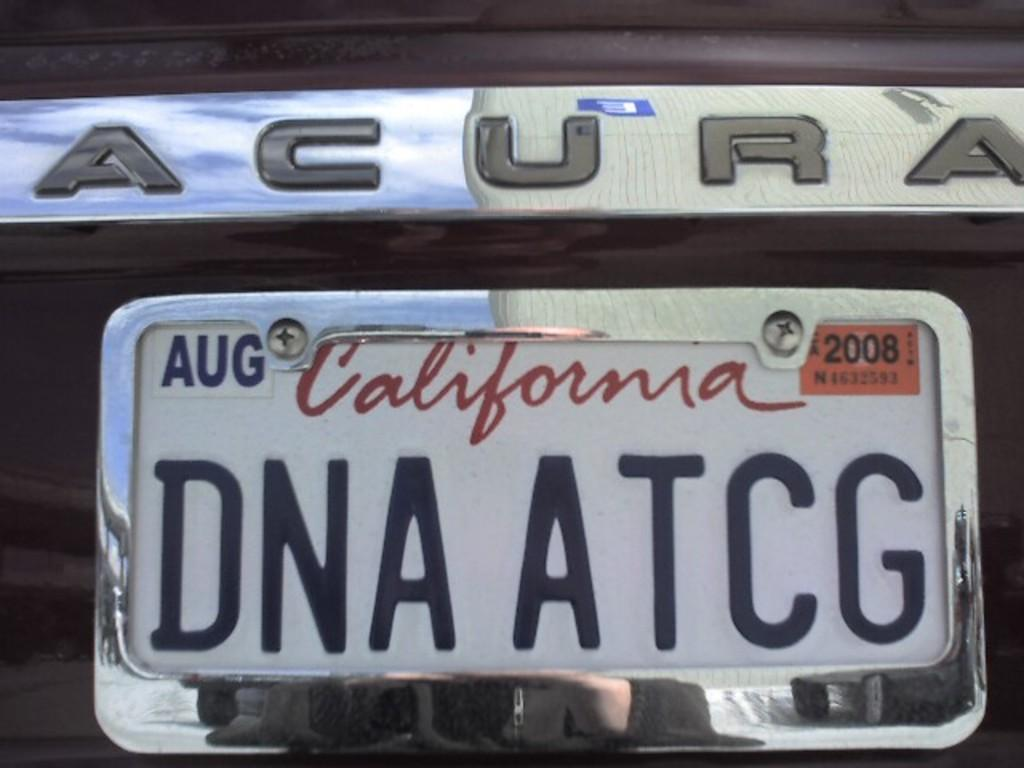<image>
Write a terse but informative summary of the picture. acura with AUG 2008 california tags DNA ATCG 